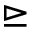Convert formula to latex. <formula><loc_0><loc_0><loc_500><loc_500>\triangleright e q</formula> 